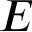Convert formula to latex. <formula><loc_0><loc_0><loc_500><loc_500>E</formula> 